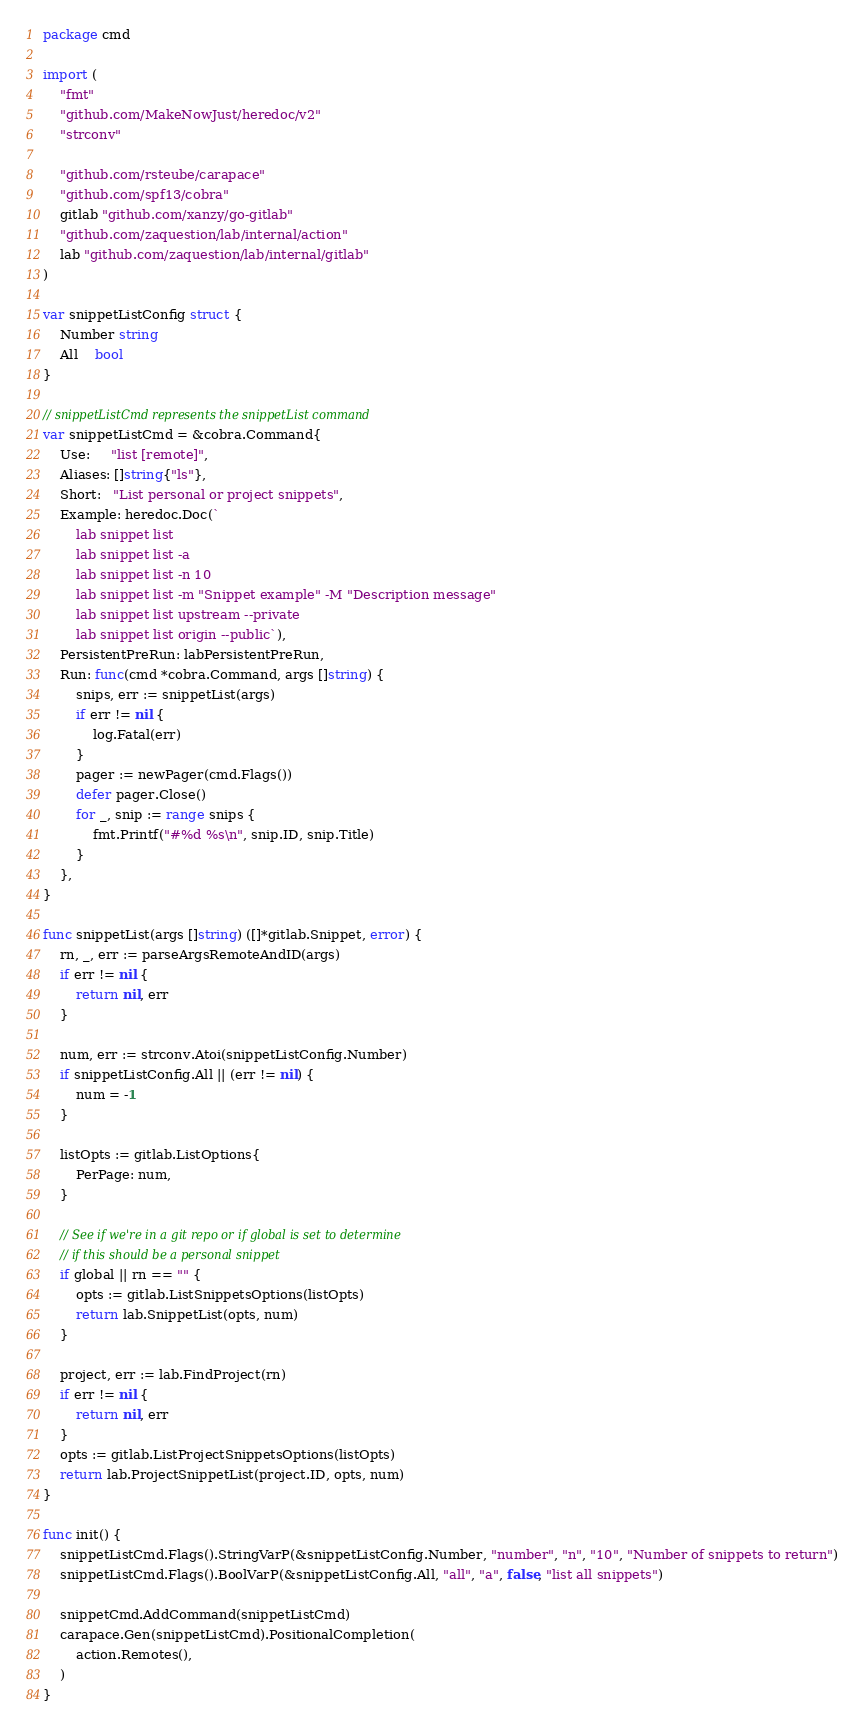Convert code to text. <code><loc_0><loc_0><loc_500><loc_500><_Go_>package cmd

import (
	"fmt"
	"github.com/MakeNowJust/heredoc/v2"
	"strconv"

	"github.com/rsteube/carapace"
	"github.com/spf13/cobra"
	gitlab "github.com/xanzy/go-gitlab"
	"github.com/zaquestion/lab/internal/action"
	lab "github.com/zaquestion/lab/internal/gitlab"
)

var snippetListConfig struct {
	Number string
	All    bool
}

// snippetListCmd represents the snippetList command
var snippetListCmd = &cobra.Command{
	Use:     "list [remote]",
	Aliases: []string{"ls"},
	Short:   "List personal or project snippets",
	Example: heredoc.Doc(`
		lab snippet list
		lab snippet list -a
		lab snippet list -n 10
		lab snippet list -m "Snippet example" -M "Description message"
		lab snippet list upstream --private
		lab snippet list origin --public`),
	PersistentPreRun: labPersistentPreRun,
	Run: func(cmd *cobra.Command, args []string) {
		snips, err := snippetList(args)
		if err != nil {
			log.Fatal(err)
		}
		pager := newPager(cmd.Flags())
		defer pager.Close()
		for _, snip := range snips {
			fmt.Printf("#%d %s\n", snip.ID, snip.Title)
		}
	},
}

func snippetList(args []string) ([]*gitlab.Snippet, error) {
	rn, _, err := parseArgsRemoteAndID(args)
	if err != nil {
		return nil, err
	}

	num, err := strconv.Atoi(snippetListConfig.Number)
	if snippetListConfig.All || (err != nil) {
		num = -1
	}

	listOpts := gitlab.ListOptions{
		PerPage: num,
	}

	// See if we're in a git repo or if global is set to determine
	// if this should be a personal snippet
	if global || rn == "" {
		opts := gitlab.ListSnippetsOptions(listOpts)
		return lab.SnippetList(opts, num)
	}

	project, err := lab.FindProject(rn)
	if err != nil {
		return nil, err
	}
	opts := gitlab.ListProjectSnippetsOptions(listOpts)
	return lab.ProjectSnippetList(project.ID, opts, num)
}

func init() {
	snippetListCmd.Flags().StringVarP(&snippetListConfig.Number, "number", "n", "10", "Number of snippets to return")
	snippetListCmd.Flags().BoolVarP(&snippetListConfig.All, "all", "a", false, "list all snippets")

	snippetCmd.AddCommand(snippetListCmd)
	carapace.Gen(snippetListCmd).PositionalCompletion(
		action.Remotes(),
	)
}
</code> 